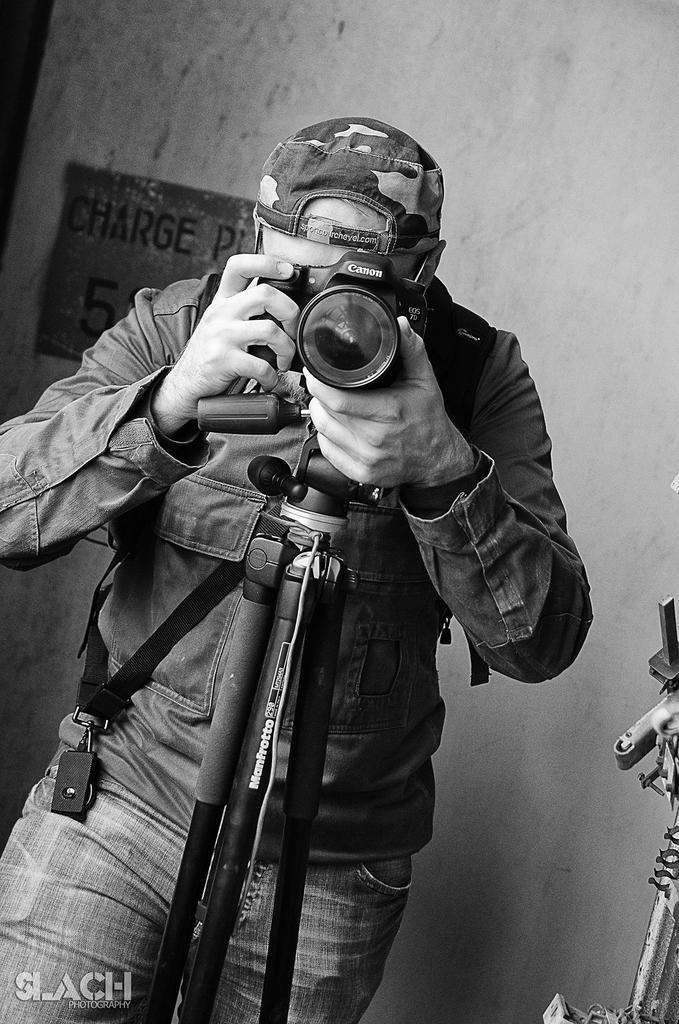What is the color of the wall in the image? The wall in the image is white. What is the man in the image doing? The man is standing in the image. What object is present in the image that is commonly used for capturing images? There is a camera in the image. Where is the store located in the image? There is no store present in the image. What type of linen is draped over the camera in the image? There is no linen present in the image, and the camera is not covered. 